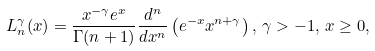<formula> <loc_0><loc_0><loc_500><loc_500>L ^ { \gamma } _ { n } ( x ) = \frac { x ^ { - \gamma } e ^ { x } } { \Gamma ( n + 1 ) } \frac { d ^ { n } } { d x ^ { n } } \left ( e ^ { - x } x ^ { n + \gamma } \right ) , \, \gamma > - 1 , \, x \geq 0 ,</formula> 